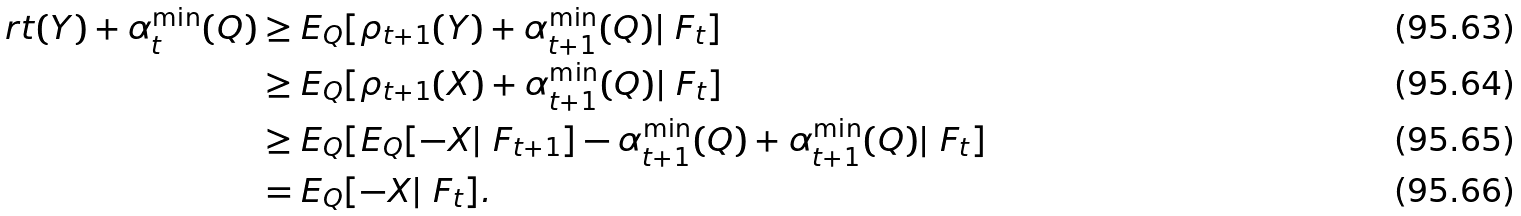<formula> <loc_0><loc_0><loc_500><loc_500>\ r t ( Y ) + \alpha _ { t } ^ { \min } ( Q ) & \geq E _ { Q } [ \rho _ { t + 1 } ( Y ) + \alpha _ { t + 1 } ^ { \min } ( Q ) | \ F _ { t } ] \\ & \geq E _ { Q } [ \rho _ { t + 1 } ( X ) + \alpha _ { t + 1 } ^ { \min } ( Q ) | \ F _ { t } ] \\ & \geq E _ { Q } [ E _ { Q } [ - X | \ F _ { t + 1 } ] - \alpha _ { t + 1 } ^ { \min } ( Q ) + \alpha _ { t + 1 } ^ { \min } ( Q ) | \ F _ { t } ] \\ & = E _ { Q } [ - X | \ F _ { t } ] .</formula> 